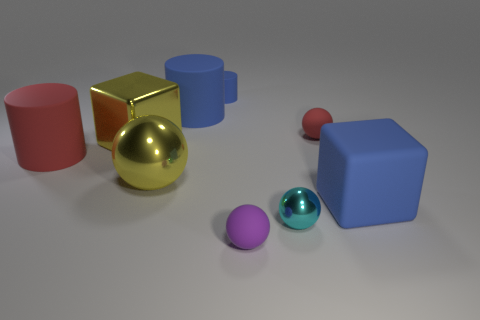Subtract all small cylinders. How many cylinders are left? 2 Add 1 blue cubes. How many objects exist? 10 Subtract all red spheres. How many spheres are left? 3 Subtract all balls. How many objects are left? 5 Subtract 1 cubes. How many cubes are left? 1 Subtract all yellow cubes. Subtract all purple cylinders. How many cubes are left? 1 Subtract all green cylinders. How many blue balls are left? 0 Subtract all shiny objects. Subtract all blue matte blocks. How many objects are left? 5 Add 6 large metallic cubes. How many large metallic cubes are left? 7 Add 8 small matte cylinders. How many small matte cylinders exist? 9 